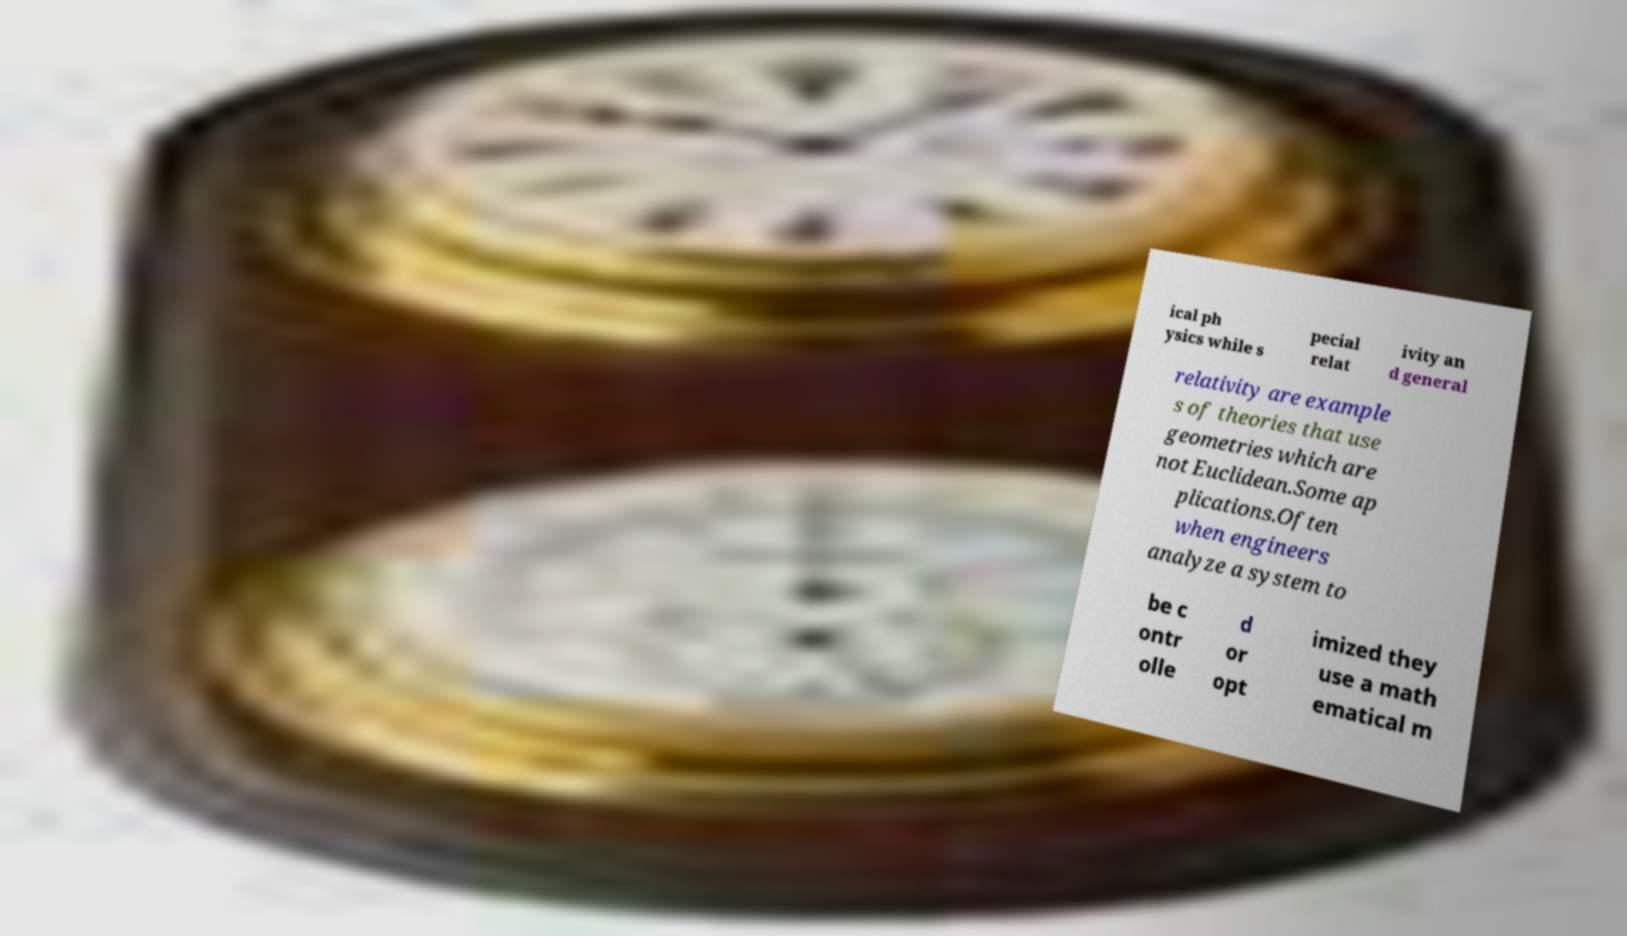Could you extract and type out the text from this image? ical ph ysics while s pecial relat ivity an d general relativity are example s of theories that use geometries which are not Euclidean.Some ap plications.Often when engineers analyze a system to be c ontr olle d or opt imized they use a math ematical m 